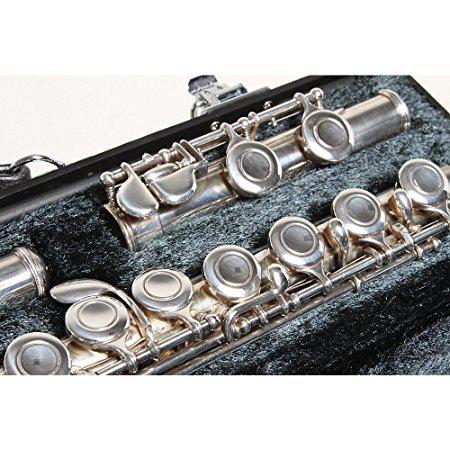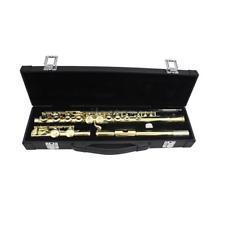The first image is the image on the left, the second image is the image on the right. For the images displayed, is the sentence "One of the instrument cases is completely closed." factually correct? Answer yes or no. No. The first image is the image on the left, the second image is the image on the right. For the images shown, is this caption "In the image pair there are two flutes propped over their carrying cases" true? Answer yes or no. No. 